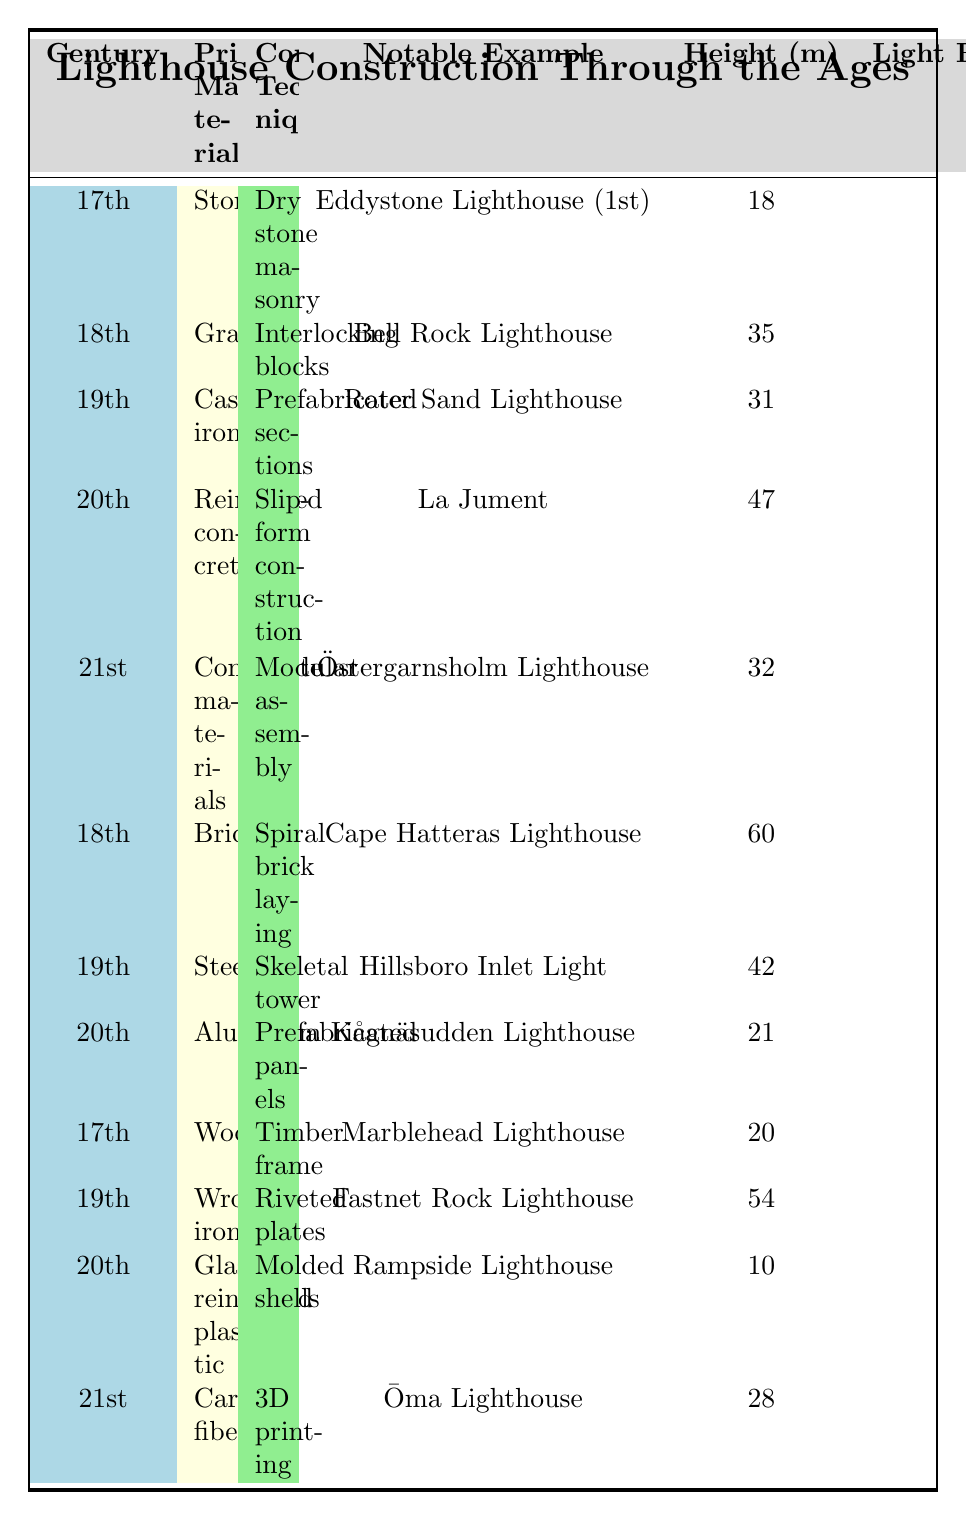What is the tallest lighthouse listed in the table? The table shows multiple lighthouses with their heights, and the tallest one is the Cape Hatteras Lighthouse at 60 meters.
Answer: 60 meters Which construction technique was used for the Eddystone Lighthouse? The table indicates that the Eddystone Lighthouse, built in the 17th century, used the dry stone masonry technique.
Answer: Dry stone masonry Which primary material was used for the lighthouse with the longest light range? The table shows that the Hillsboro Inlet Light has the longest light range of 45 kilometers, and it was made of steel.
Answer: Steel How does the light range of the tallest lighthouse compare to that of the second tallest? The tallest lighthouse is Cape Hatteras at a height of 60 meters with a light range of 40 kilometers; the second tallest is the Fastnet Rock Lighthouse at 54 meters with a range of 43 kilometers. The difference in light range is (43 - 40) = 3 kilometers.
Answer: 3 kilometers Is there any lighthouse constructed with aluminum? Yes, according to the table, the Kågnäsudden Lighthouse is constructed with aluminum.
Answer: Yes What are the primary materials used in the 19th century lighthouses listed? By checking all the entries for the 19th century, the primary materials used in the lighthouses are cast iron, steel, and wrought iron.
Answer: Cast iron, steel, wrought iron What is the average height of the 20th-century lighthouses? The heights of the 20th-century lighthouses are 47, 21, and 10 meters. Summing these gives 47 + 21 + 10 = 78 meters; dividing by the count (3) gives an average height of 78/3 = 26 meters.
Answer: 26 meters Which century predominantly features brick as a primary material? The table indicates that brick was predominantly featured in the 18th century, specifically with the Cape Hatteras Lighthouse entry.
Answer: 18th century Which lighthouse has the highest light range from the 21st century, and what is its light range? The Östergarnsholm Lighthouse is from the 21st century and has the highest light range of 42 kilometers, as shown in the table.
Answer: Östergarnsholm Lighthouse, 42 kilometers Explain the trend in the primary materials used for lighthouse construction from the 17th to the 21st century. Observing the table, we can see a transition from traditional materials like stone and wood in the 17th century to more modern materials such as composite and carbon fiber in the 21st century. This indicates advancements in technology and materials science over time, allowing for more innovative designs and potentially better durability.
Answer: Transition from stone and wood to composite and carbon fiber 